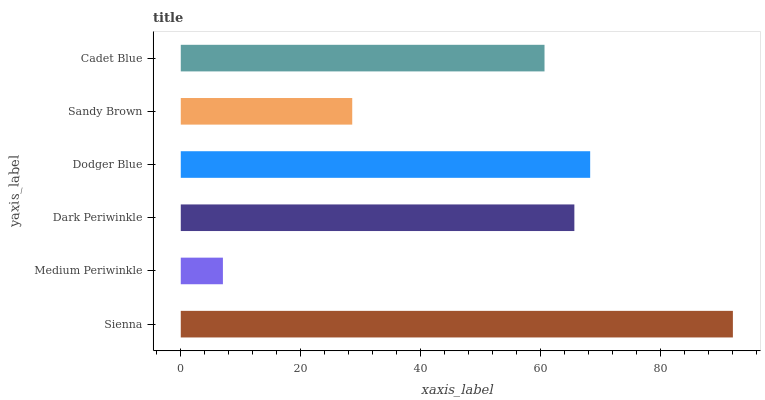Is Medium Periwinkle the minimum?
Answer yes or no. Yes. Is Sienna the maximum?
Answer yes or no. Yes. Is Dark Periwinkle the minimum?
Answer yes or no. No. Is Dark Periwinkle the maximum?
Answer yes or no. No. Is Dark Periwinkle greater than Medium Periwinkle?
Answer yes or no. Yes. Is Medium Periwinkle less than Dark Periwinkle?
Answer yes or no. Yes. Is Medium Periwinkle greater than Dark Periwinkle?
Answer yes or no. No. Is Dark Periwinkle less than Medium Periwinkle?
Answer yes or no. No. Is Dark Periwinkle the high median?
Answer yes or no. Yes. Is Cadet Blue the low median?
Answer yes or no. Yes. Is Cadet Blue the high median?
Answer yes or no. No. Is Dark Periwinkle the low median?
Answer yes or no. No. 